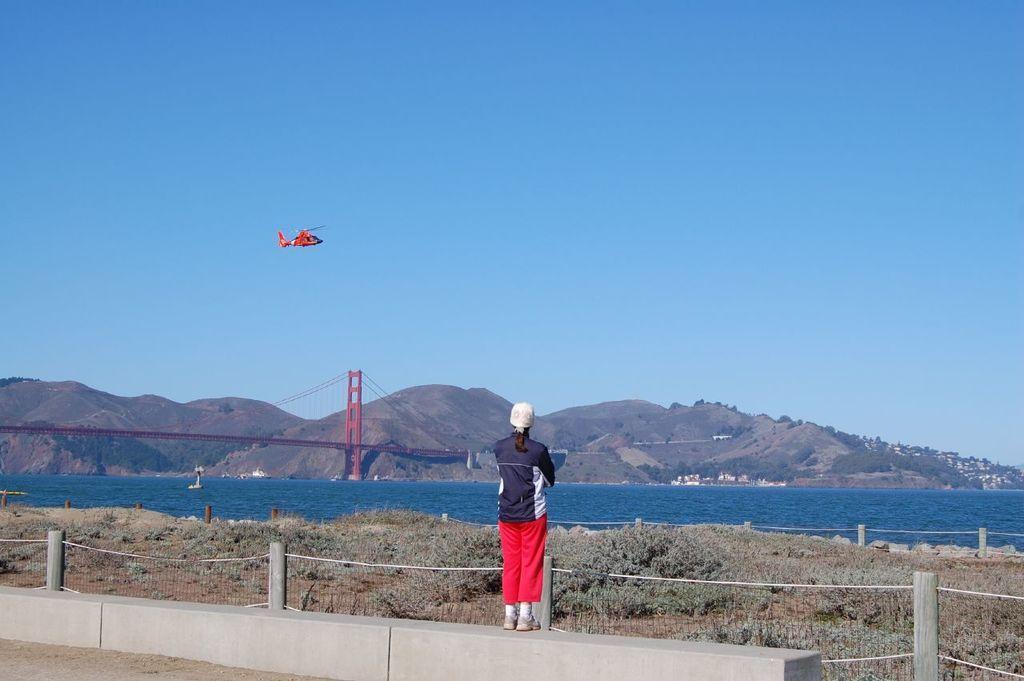Can you describe this image briefly? In this image I can see one person is standing over here and I can see this person is wearing white colour cap, a jacket, red pant and white shoes. In the background I can see grass, bridgewater, the sky and a red colour helicopter in air. 